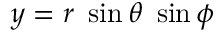<formula> <loc_0><loc_0><loc_500><loc_500>y = r \sin \theta \sin \phi</formula> 